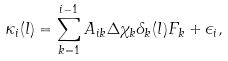Convert formula to latex. <formula><loc_0><loc_0><loc_500><loc_500>\kappa _ { i } ( l ) = \sum _ { k = 1 } ^ { i - 1 } A _ { i k } \Delta \chi _ { k } \delta _ { k } ( l ) F _ { k } + \epsilon _ { i } ,</formula> 